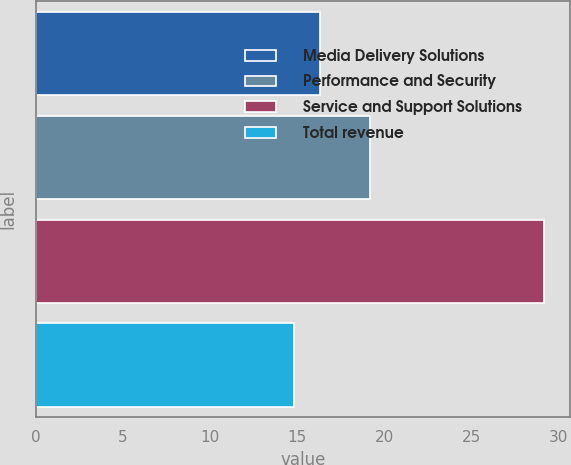<chart> <loc_0><loc_0><loc_500><loc_500><bar_chart><fcel>Media Delivery Solutions<fcel>Performance and Security<fcel>Service and Support Solutions<fcel>Total revenue<nl><fcel>16.3<fcel>19.2<fcel>29.2<fcel>14.8<nl></chart> 